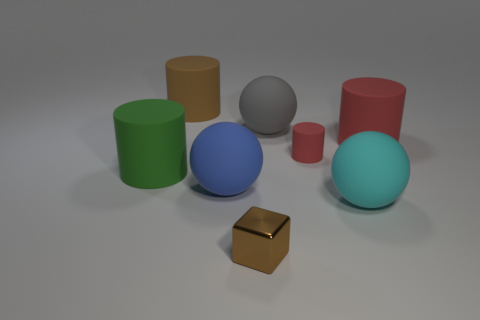How many red cylinders must be subtracted to get 1 red cylinders? 1 Subtract all cyan cubes. How many red cylinders are left? 2 Subtract all small cylinders. How many cylinders are left? 3 Subtract all green cylinders. How many cylinders are left? 3 Subtract 1 balls. How many balls are left? 2 Add 1 large gray metal blocks. How many objects exist? 9 Subtract all blue cylinders. Subtract all yellow spheres. How many cylinders are left? 4 Subtract all blocks. How many objects are left? 7 Add 4 gray spheres. How many gray spheres are left? 5 Add 8 large red matte objects. How many large red matte objects exist? 9 